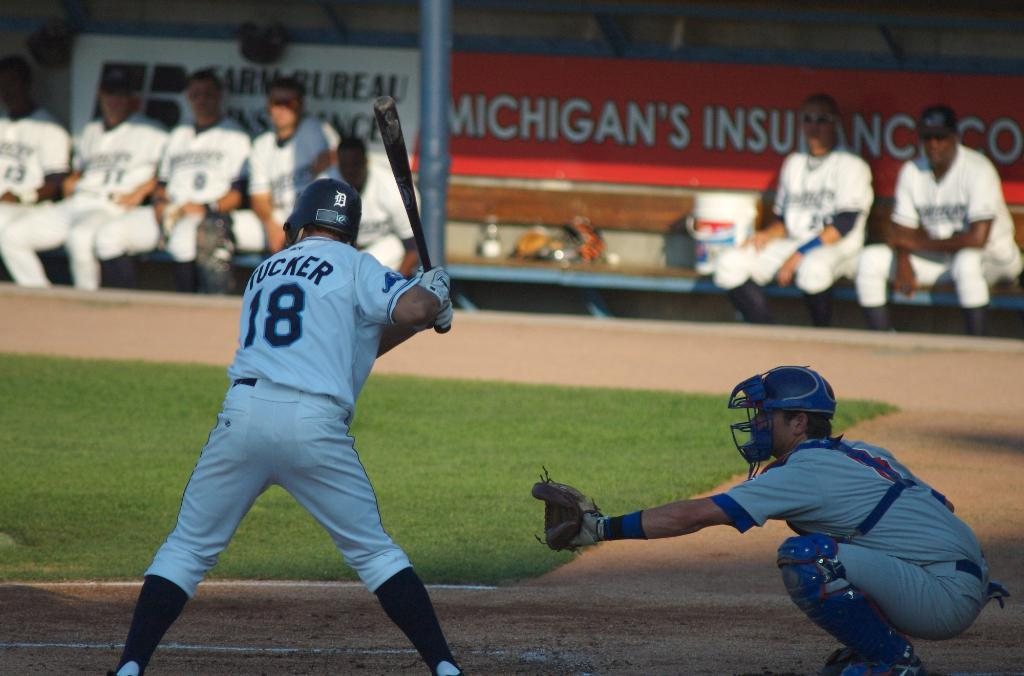Provide a one-sentence caption for the provided image. The baseball game is sponsored by Michigan's Insurance Co. 